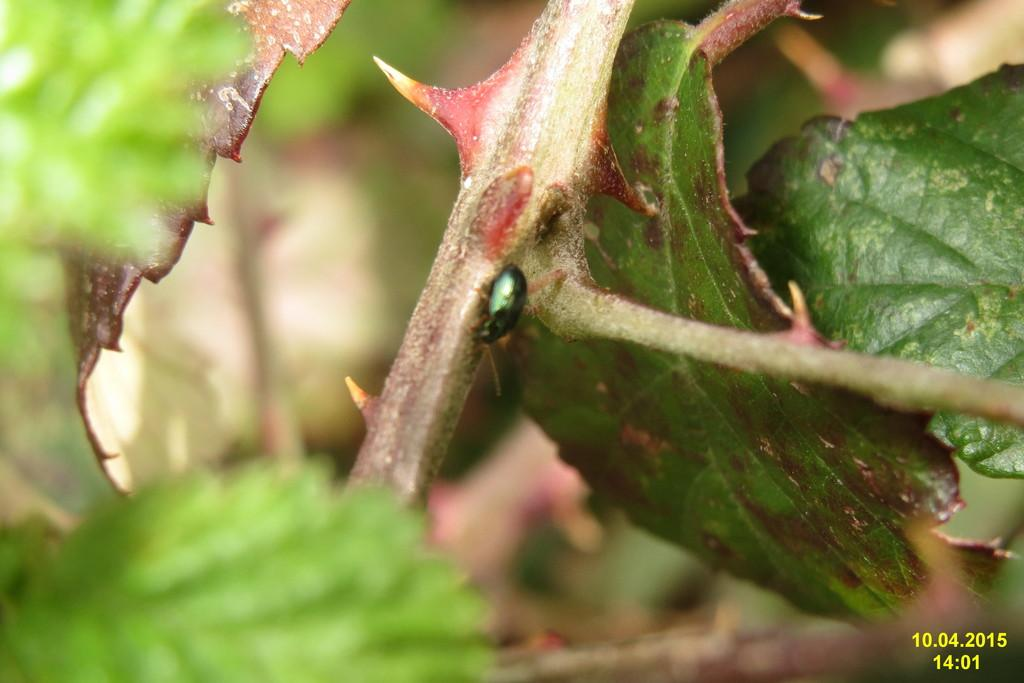What type of creature is in the image? There is an insect in the image. Where is the insect located? The insect is on a plant. What type of hair can be seen on the ground in the image? There is no hair present on the ground in the image. What subject is the insect teaching in the image? The insect is not teaching any subject in the image, as insects do not have the ability to teach. 